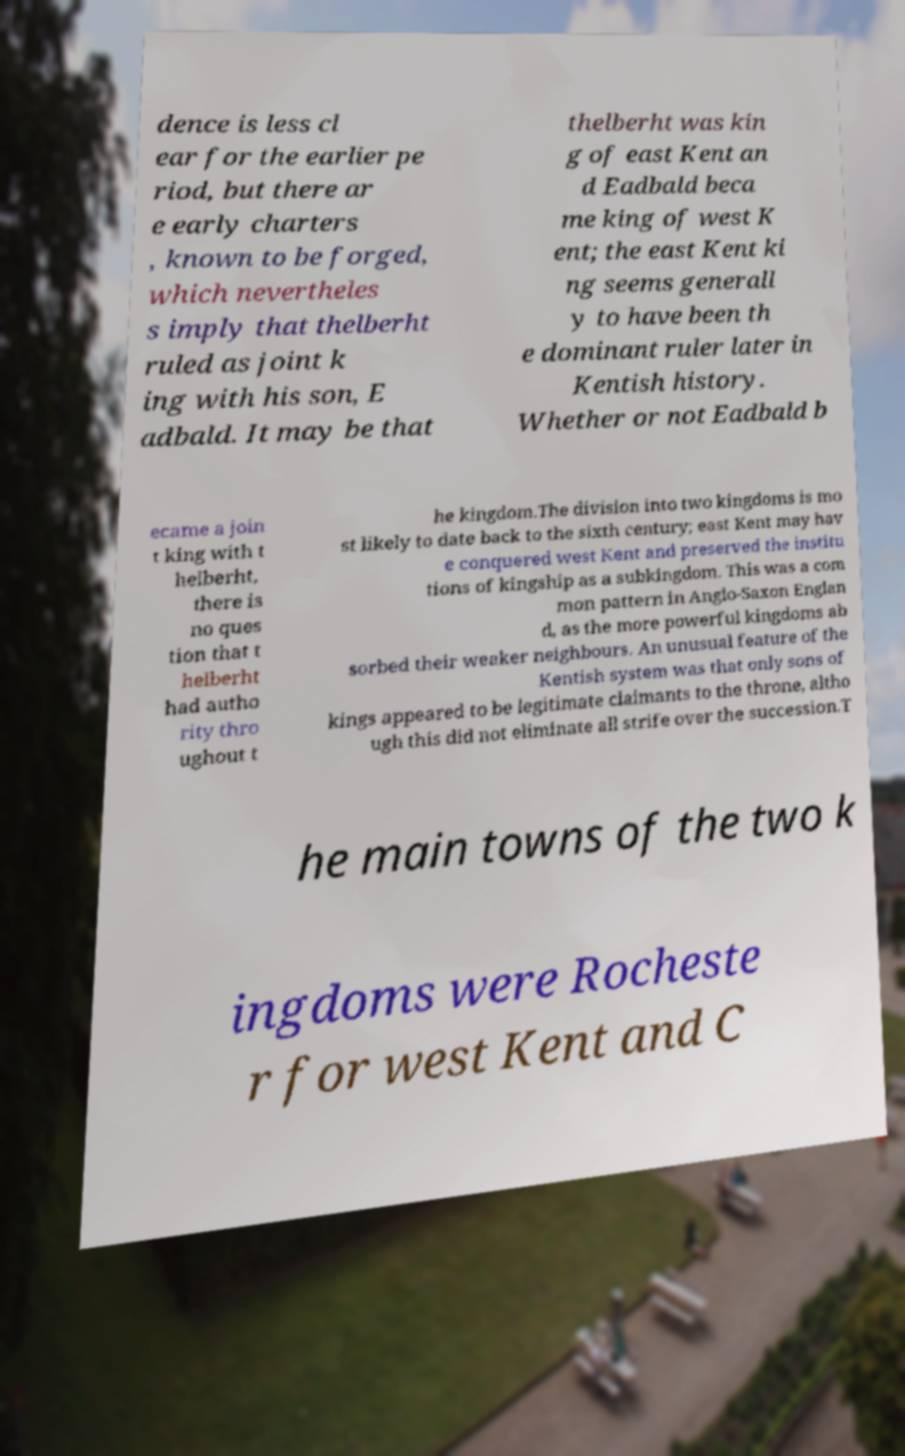For documentation purposes, I need the text within this image transcribed. Could you provide that? dence is less cl ear for the earlier pe riod, but there ar e early charters , known to be forged, which nevertheles s imply that thelberht ruled as joint k ing with his son, E adbald. It may be that thelberht was kin g of east Kent an d Eadbald beca me king of west K ent; the east Kent ki ng seems generall y to have been th e dominant ruler later in Kentish history. Whether or not Eadbald b ecame a join t king with t helberht, there is no ques tion that t helberht had autho rity thro ughout t he kingdom.The division into two kingdoms is mo st likely to date back to the sixth century; east Kent may hav e conquered west Kent and preserved the institu tions of kingship as a subkingdom. This was a com mon pattern in Anglo-Saxon Englan d, as the more powerful kingdoms ab sorbed their weaker neighbours. An unusual feature of the Kentish system was that only sons of kings appeared to be legitimate claimants to the throne, altho ugh this did not eliminate all strife over the succession.T he main towns of the two k ingdoms were Rocheste r for west Kent and C 